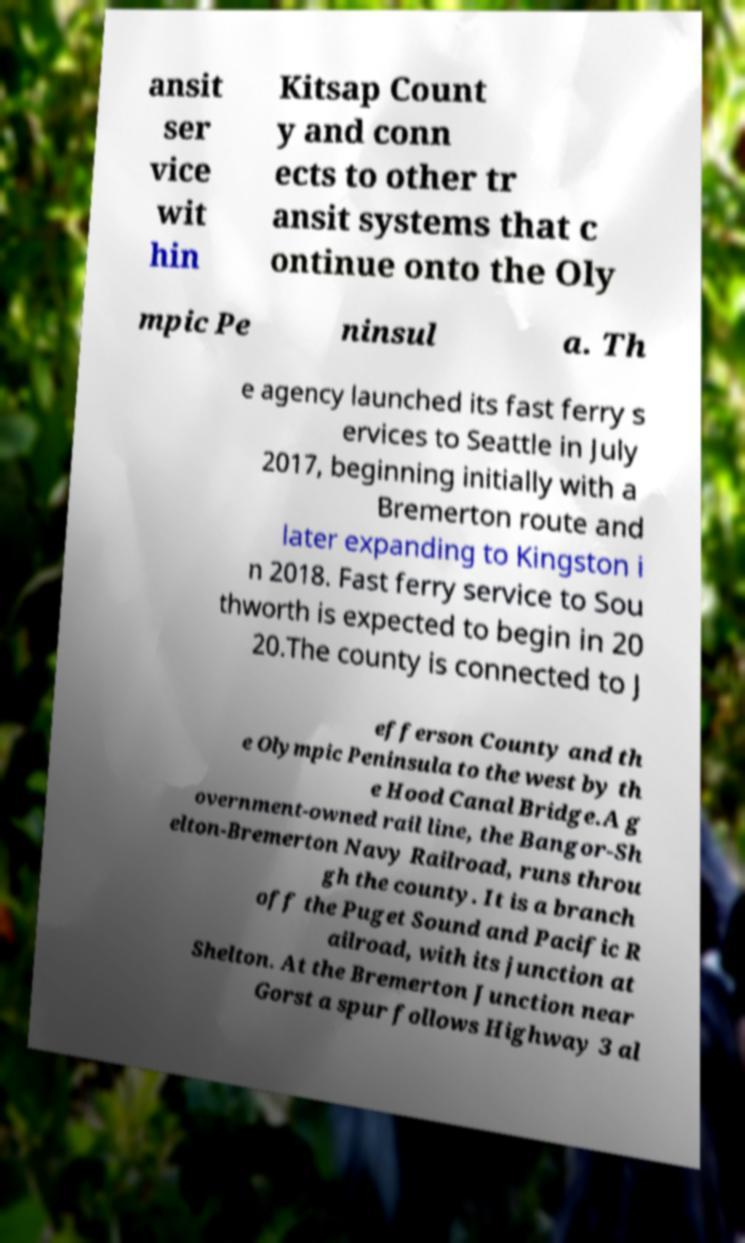For documentation purposes, I need the text within this image transcribed. Could you provide that? ansit ser vice wit hin Kitsap Count y and conn ects to other tr ansit systems that c ontinue onto the Oly mpic Pe ninsul a. Th e agency launched its fast ferry s ervices to Seattle in July 2017, beginning initially with a Bremerton route and later expanding to Kingston i n 2018. Fast ferry service to Sou thworth is expected to begin in 20 20.The county is connected to J efferson County and th e Olympic Peninsula to the west by th e Hood Canal Bridge.A g overnment-owned rail line, the Bangor-Sh elton-Bremerton Navy Railroad, runs throu gh the county. It is a branch off the Puget Sound and Pacific R ailroad, with its junction at Shelton. At the Bremerton Junction near Gorst a spur follows Highway 3 al 